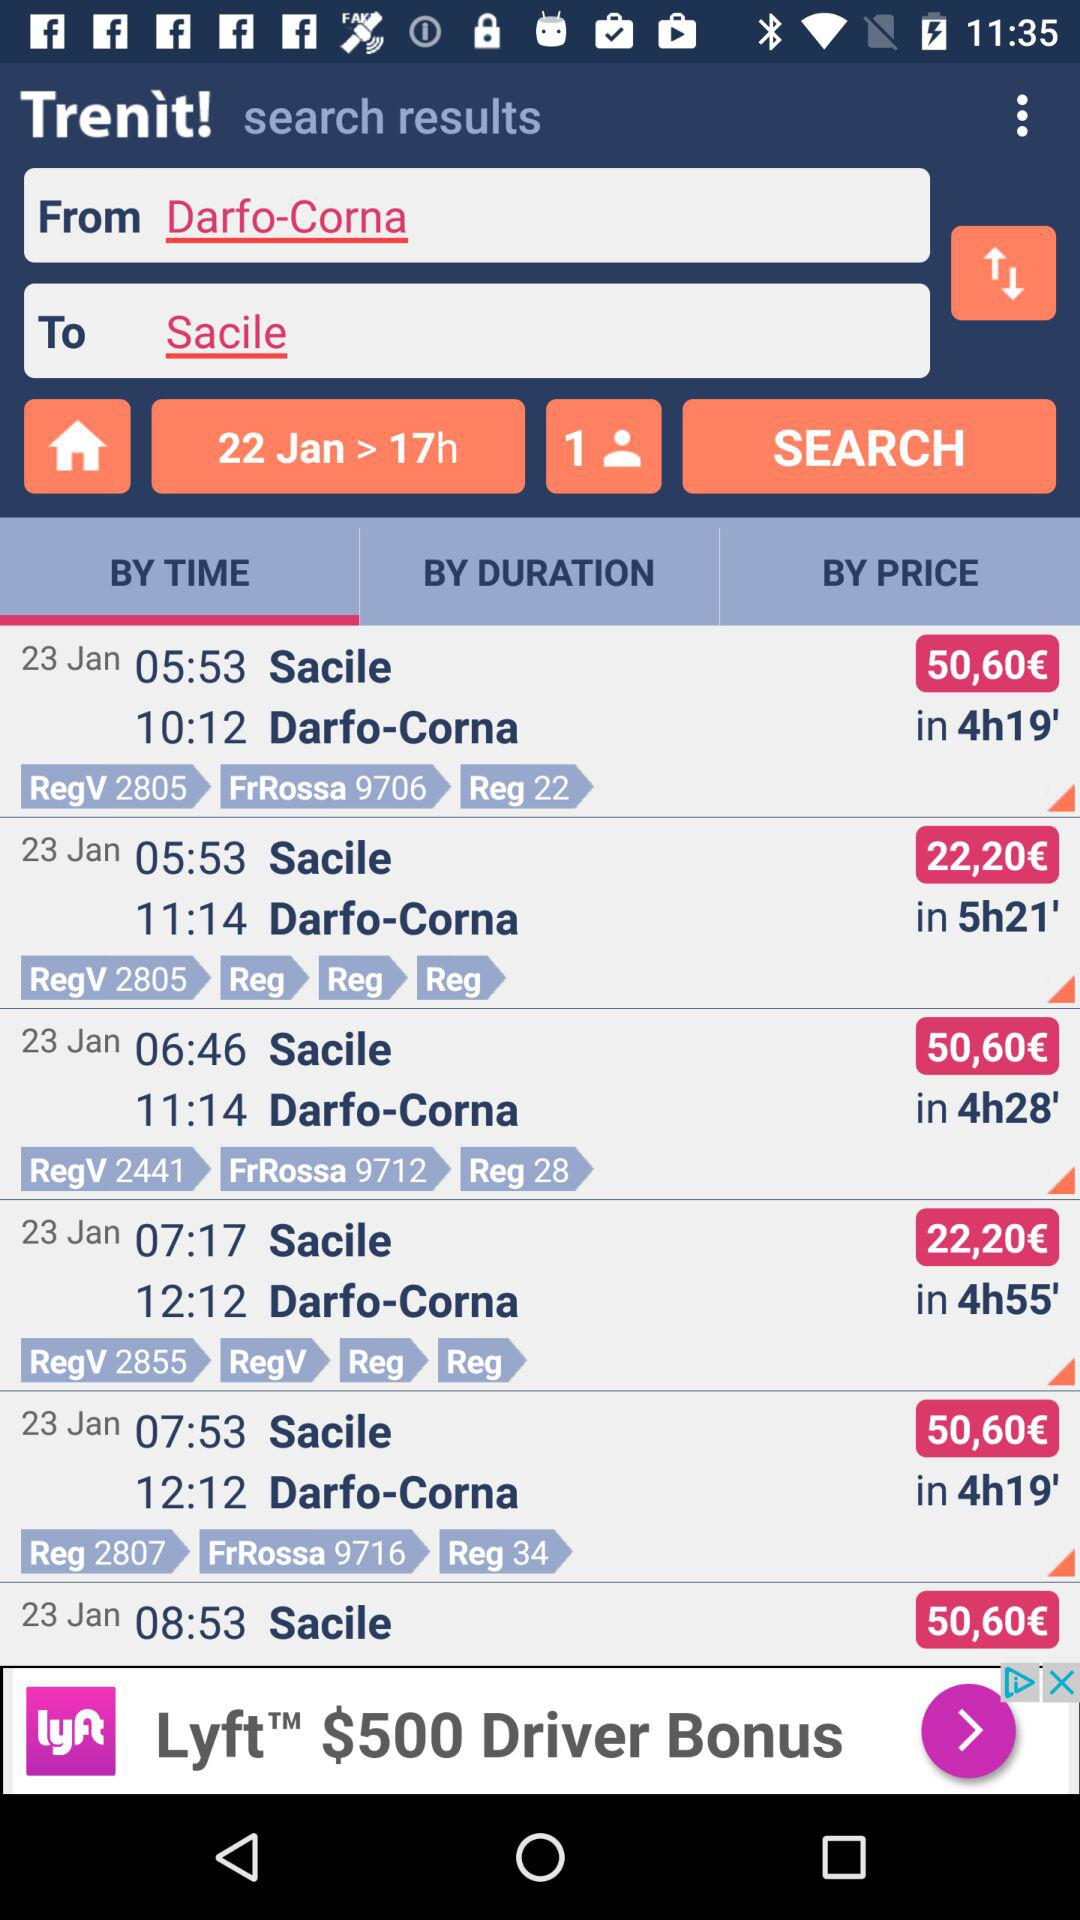What is the cost of travel on the 23rd from 7:17 to 12:12? The cost of travel is 22,20 euros. 